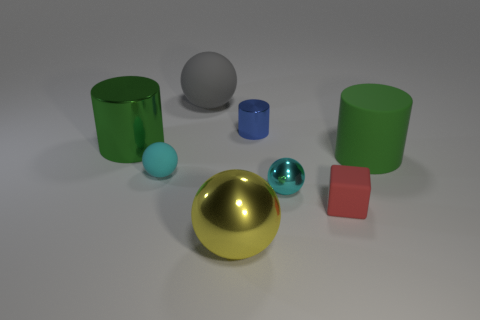Subtract all red balls. Subtract all brown blocks. How many balls are left? 4 Add 2 green matte spheres. How many objects exist? 10 Subtract all cubes. How many objects are left? 7 Subtract all tiny brown metal balls. Subtract all large matte spheres. How many objects are left? 7 Add 6 gray things. How many gray things are left? 7 Add 8 green rubber things. How many green rubber things exist? 9 Subtract 0 purple blocks. How many objects are left? 8 